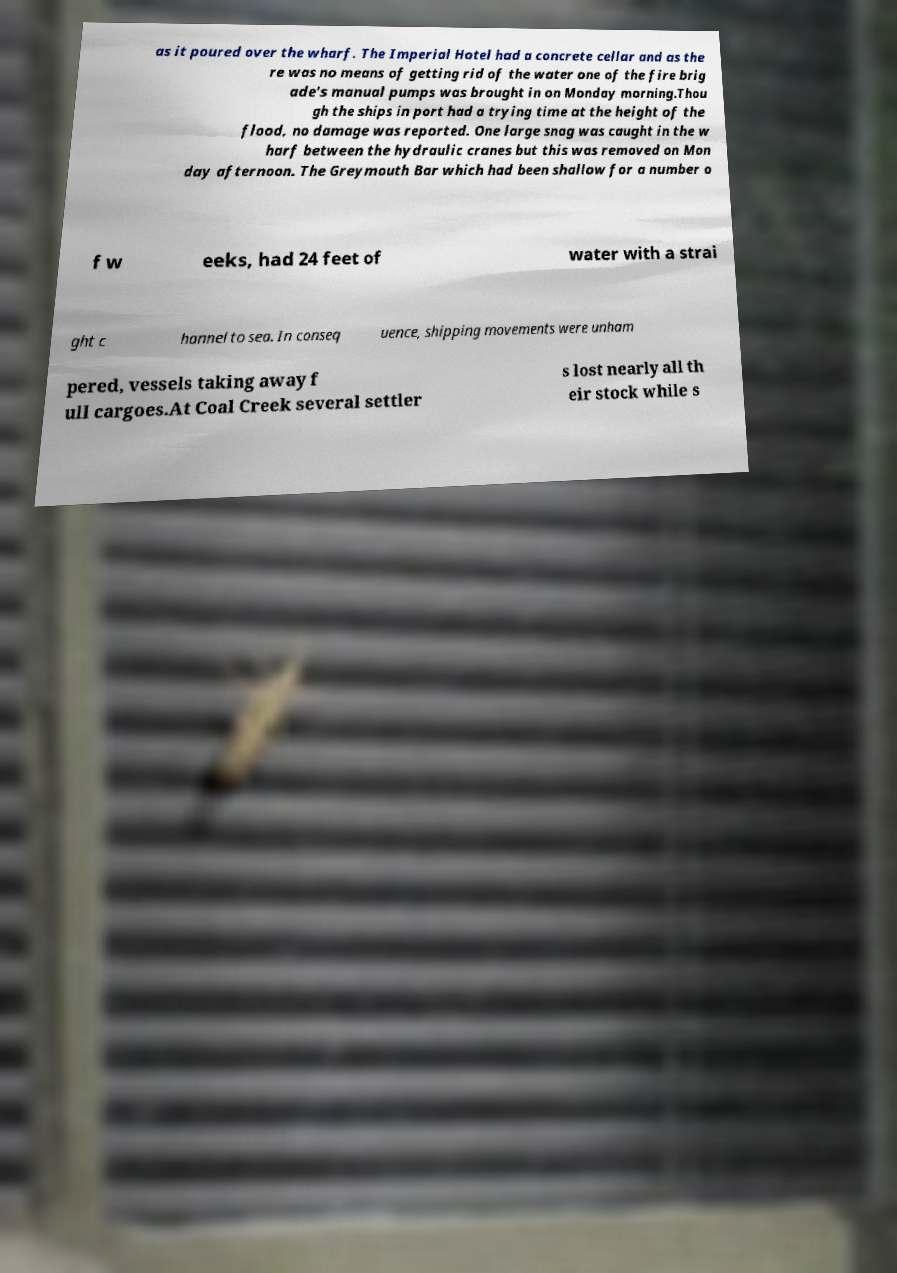Please identify and transcribe the text found in this image. as it poured over the wharf. The Imperial Hotel had a concrete cellar and as the re was no means of getting rid of the water one of the fire brig ade's manual pumps was brought in on Monday morning.Thou gh the ships in port had a trying time at the height of the flood, no damage was reported. One large snag was caught in the w harf between the hydraulic cranes but this was removed on Mon day afternoon. The Greymouth Bar which had been shallow for a number o f w eeks, had 24 feet of water with a strai ght c hannel to sea. In conseq uence, shipping movements were unham pered, vessels taking away f ull cargoes.At Coal Creek several settler s lost nearly all th eir stock while s 